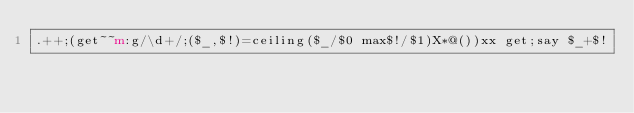Convert code to text. <code><loc_0><loc_0><loc_500><loc_500><_Perl_>.++;(get~~m:g/\d+/;($_,$!)=ceiling($_/$0 max$!/$1)X*@())xx get;say $_+$!</code> 